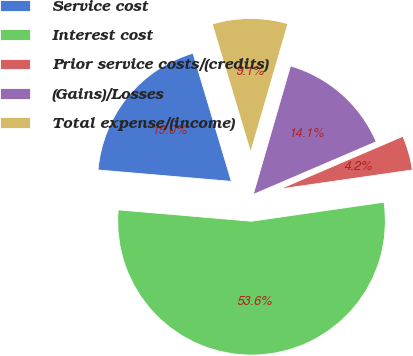Convert chart to OTSL. <chart><loc_0><loc_0><loc_500><loc_500><pie_chart><fcel>Service cost<fcel>Interest cost<fcel>Prior service costs/(credits)<fcel>(Gains)/Losses<fcel>Total expense/(income)<nl><fcel>19.01%<fcel>53.63%<fcel>4.17%<fcel>14.06%<fcel>9.12%<nl></chart> 